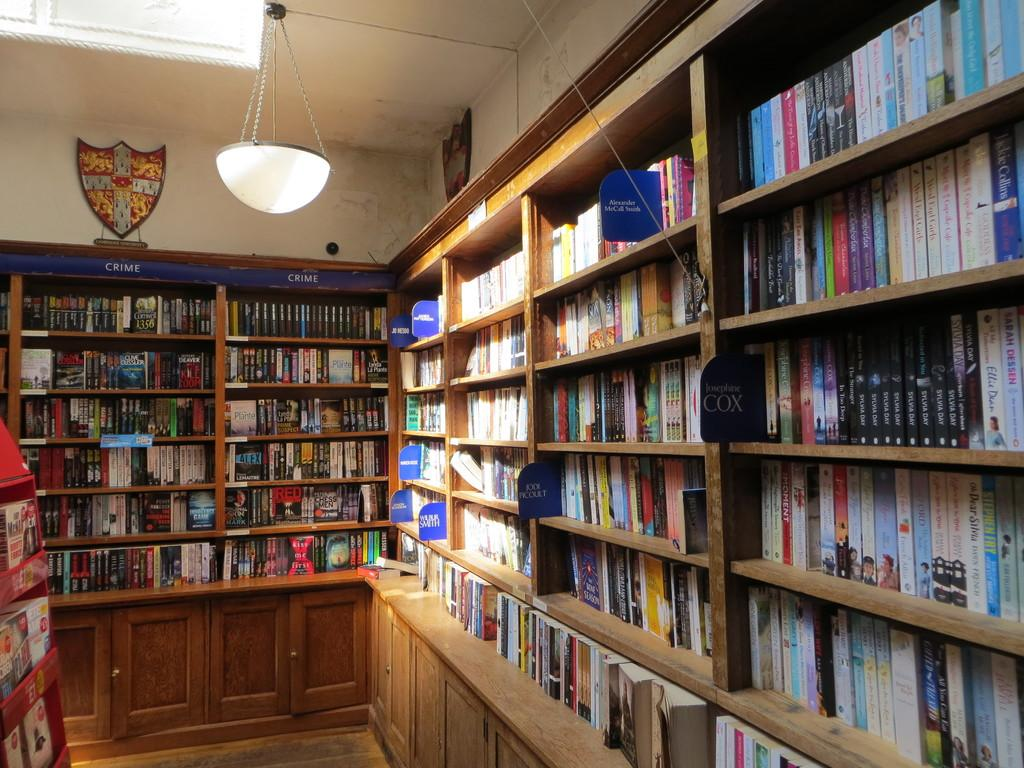What type of lighting is present in the image? There is an electric light hanging from the roof in the image. What can be seen on the walls in the image? Mementos are attached to the walls in the image. What type of items are arranged in shelves or cupboards? There are many books arranged in shelves or cupboards in the image. Can you see an art piece hanging from the ceiling in the image? There is no art piece hanging from the ceiling in the image; it only mentions an electric light hanging from the roof. Is there an airplane parked in the room in the image? There is no airplane present in the image; it only mentions books, mementos, and an electric light. 